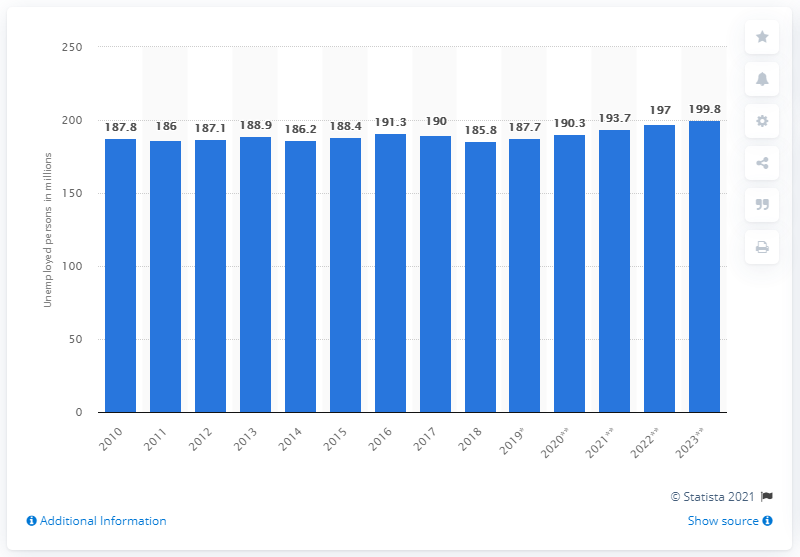Mention a couple of crucial points in this snapshot. In 2018, there were 185.8 unemployed people. 